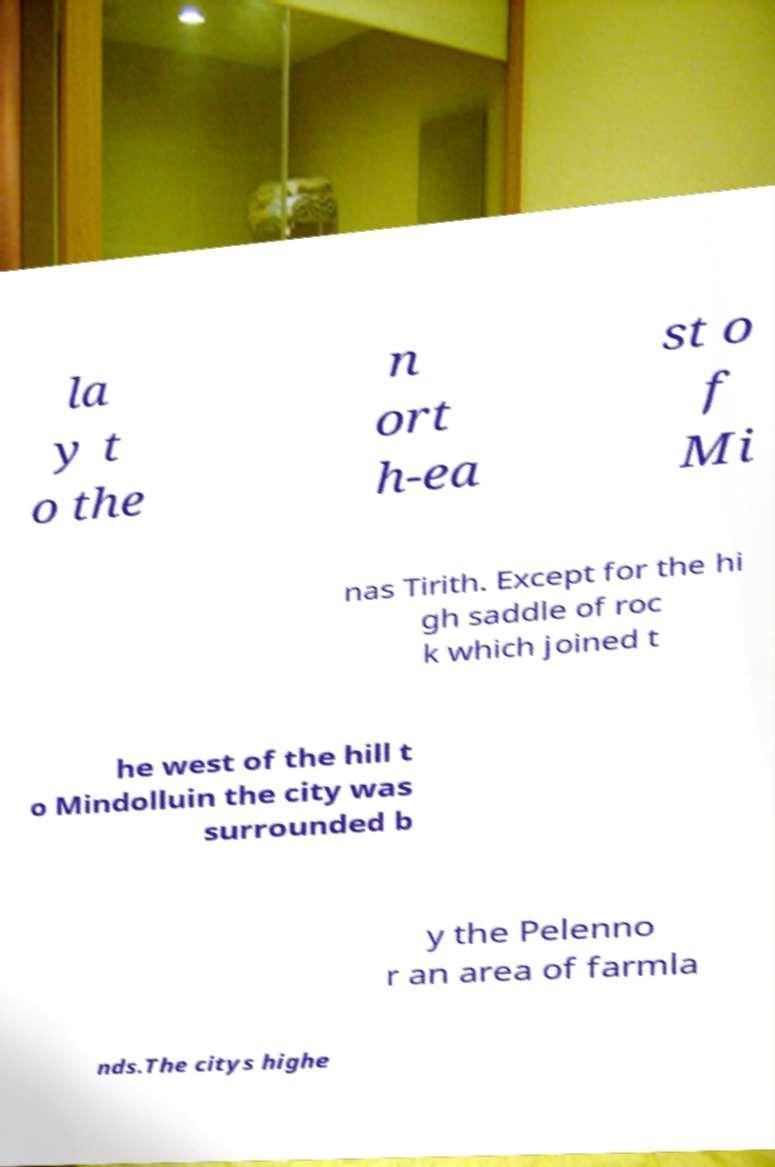Can you read and provide the text displayed in the image?This photo seems to have some interesting text. Can you extract and type it out for me? la y t o the n ort h-ea st o f Mi nas Tirith. Except for the hi gh saddle of roc k which joined t he west of the hill t o Mindolluin the city was surrounded b y the Pelenno r an area of farmla nds.The citys highe 